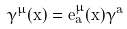Convert formula to latex. <formula><loc_0><loc_0><loc_500><loc_500>\gamma ^ { \mu } ( x ) = e ^ { \mu } _ { a } ( x ) \gamma ^ { a }</formula> 